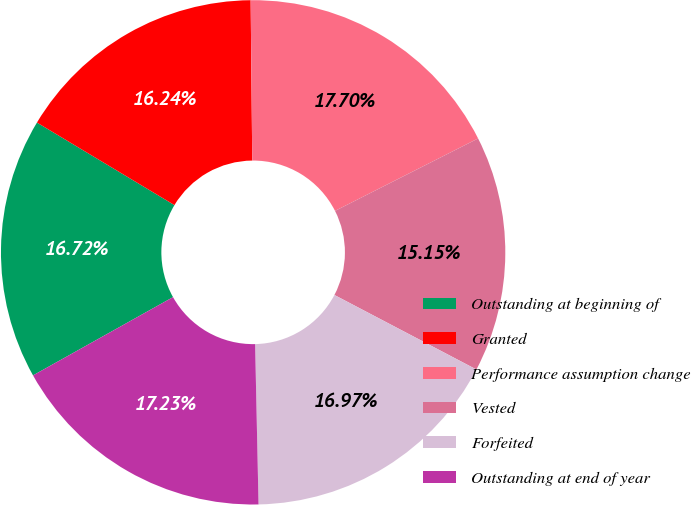Convert chart to OTSL. <chart><loc_0><loc_0><loc_500><loc_500><pie_chart><fcel>Outstanding at beginning of<fcel>Granted<fcel>Performance assumption change<fcel>Vested<fcel>Forfeited<fcel>Outstanding at end of year<nl><fcel>16.72%<fcel>16.24%<fcel>17.7%<fcel>15.15%<fcel>16.97%<fcel>17.23%<nl></chart> 